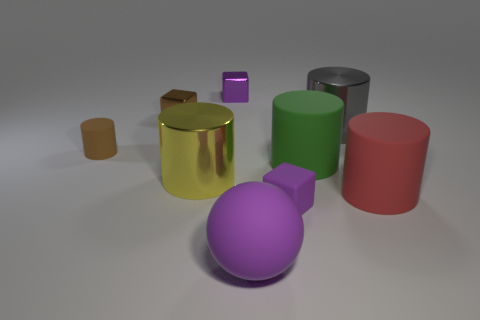How many other objects are there of the same size as the red cylinder?
Provide a short and direct response. 4. What is the size of the matte thing to the left of the large yellow shiny cylinder?
Offer a very short reply. Small. Is the small purple block behind the red cylinder made of the same material as the red object?
Offer a terse response. No. How many cylinders are both behind the large yellow cylinder and on the right side of the big yellow shiny object?
Make the answer very short. 2. What is the size of the rubber cylinder to the left of the tiny purple metallic block that is behind the big green matte cylinder?
Provide a short and direct response. Small. Are there more big yellow shiny objects than small brown things?
Provide a succinct answer. No. There is a block that is in front of the gray metallic cylinder; does it have the same color as the rubber object in front of the tiny purple rubber thing?
Offer a very short reply. Yes. Is there a brown cylinder behind the shiny thing that is right of the green rubber cylinder?
Offer a terse response. No. Is the number of big green rubber things to the left of the green matte object less than the number of small brown blocks that are in front of the large yellow metallic thing?
Ensure brevity in your answer.  No. Does the small brown block that is behind the green matte object have the same material as the purple block in front of the big gray thing?
Offer a terse response. No. 